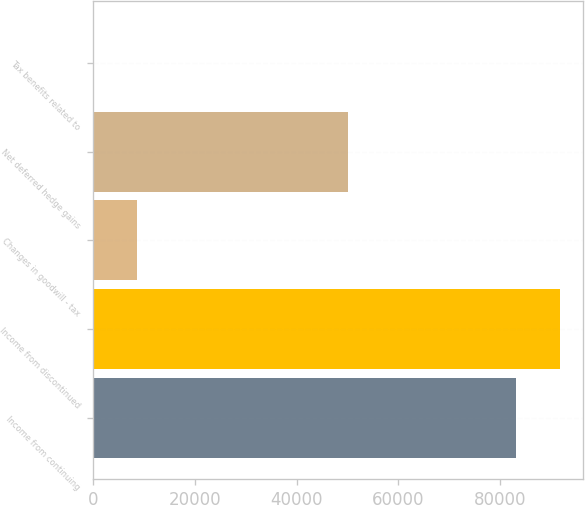<chart> <loc_0><loc_0><loc_500><loc_500><bar_chart><fcel>Income from continuing<fcel>Income from discontinued<fcel>Changes in goodwill - tax<fcel>Net deferred hedge gains<fcel>Tax benefits related to<nl><fcel>83195<fcel>91747.6<fcel>8553.6<fcel>50059<fcel>1<nl></chart> 